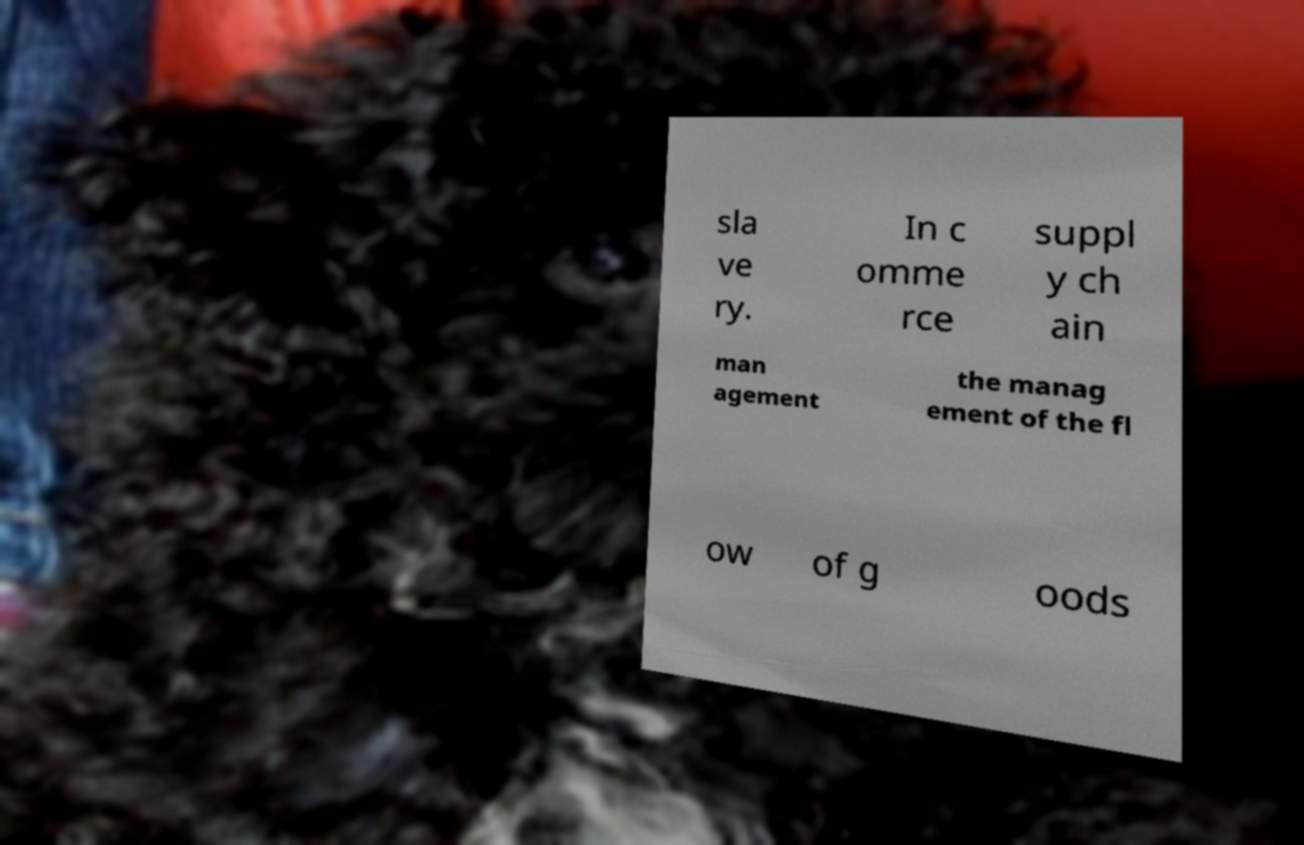What messages or text are displayed in this image? I need them in a readable, typed format. sla ve ry. In c omme rce suppl y ch ain man agement the manag ement of the fl ow of g oods 